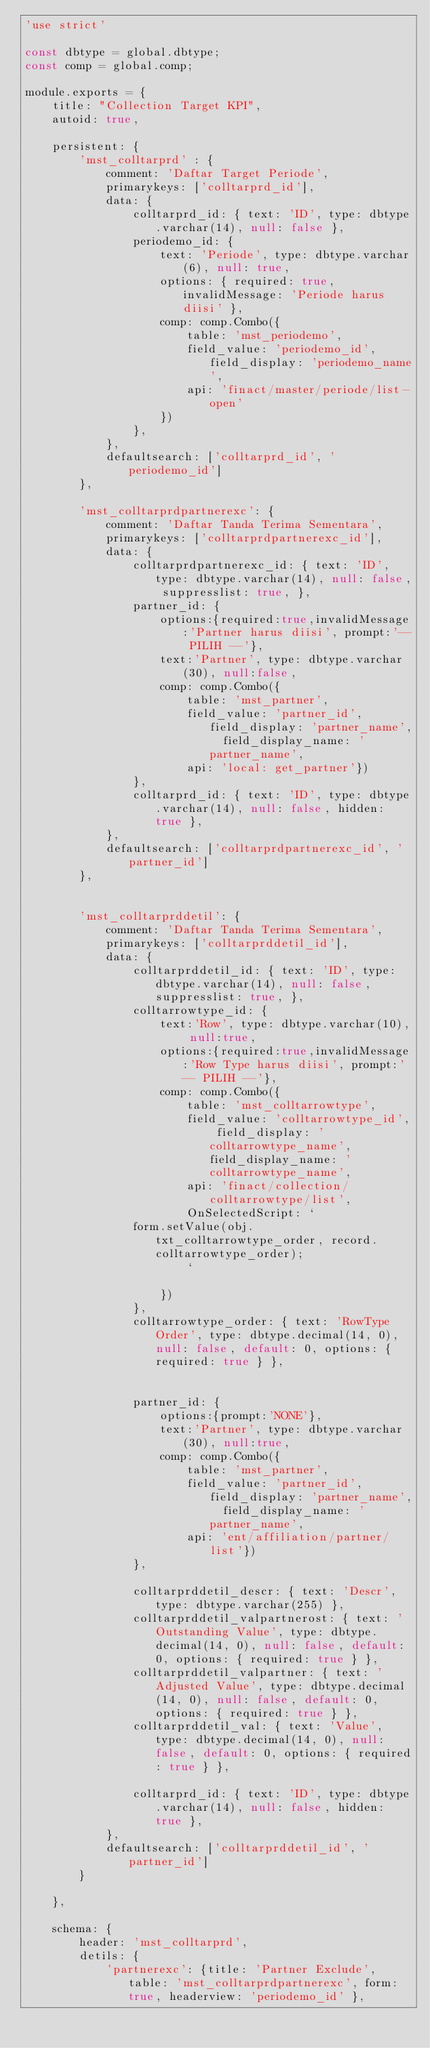Convert code to text. <code><loc_0><loc_0><loc_500><loc_500><_JavaScript_>'use strict'

const dbtype = global.dbtype;
const comp = global.comp;

module.exports = {
	title: "Collection Target KPI",
	autoid: true,

	persistent: {
		'mst_colltarprd' : {
			comment: 'Daftar Target Periode',
			primarykeys: ['colltarprd_id'],
			data: {
				colltarprd_id: { text: 'ID', type: dbtype.varchar(14), null: false },
				periodemo_id: { 
					text: 'Periode', type: dbtype.varchar(6), null: true,
					options: { required: true, invalidMessage: 'Periode harus diisi' }, 
					comp: comp.Combo({
						table: 'mst_periodemo',
						field_value: 'periodemo_id', field_display: 'periodemo_name',
						api: 'finact/master/periode/list-open'
					})				
				},
			},
			defaultsearch: ['colltarprd_id', 'periodemo_id']
		},

		'mst_colltarprdpartnerexc': {
			comment: 'Daftar Tanda Terima Sementara',
			primarykeys: ['colltarprdpartnerexc_id'],
			data: {
				colltarprdpartnerexc_id: { text: 'ID', type: dbtype.varchar(14), null: false, suppresslist: true, },
				partner_id: {
					options:{required:true,invalidMessage:'Partner harus diisi', prompt:'-- PILIH --'},
					text:'Partner', type: dbtype.varchar(30), null:false, 
					comp: comp.Combo({
						table: 'mst_partner', 
						field_value: 'partner_id', field_display: 'partner_name',  field_display_name: 'partner_name',
						api: 'local: get_partner'})
				},		
				colltarprd_id: { text: 'ID', type: dbtype.varchar(14), null: false, hidden: true },		
			},
			defaultsearch: ['colltarprdpartnerexc_id', 'partner_id']
		},


		'mst_colltarprddetil': {
			comment: 'Daftar Tanda Terima Sementara',
			primarykeys: ['colltarprddetil_id'],
			data: {
				colltarprddetil_id: { text: 'ID', type: dbtype.varchar(14), null: false, suppresslist: true, },
				colltarrowtype_id: {
					text:'Row', type: dbtype.varchar(10), null:true, 
					options:{required:true,invalidMessage:'Row Type harus diisi', prompt:'-- PILIH --'},
					comp: comp.Combo({
						table: 'mst_colltarrowtype', 
						field_value: 'colltarrowtype_id', field_display: 'colltarrowtype_name',  field_display_name: 'colltarrowtype_name',
						api: 'finact/collection/colltarrowtype/list',
						OnSelectedScript: `
				form.setValue(obj.txt_colltarrowtype_order, record.colltarrowtype_order);		
						`
					
					})
				},
				colltarrowtype_order: { text: 'RowType Order', type: dbtype.decimal(14, 0), null: false, default: 0, options: { required: true } },


				partner_id: {
					options:{prompt:'NONE'},
					text:'Partner', type: dbtype.varchar(30), null:true, 
					comp: comp.Combo({
						table: 'mst_partner', 
						field_value: 'partner_id', field_display: 'partner_name',  field_display_name: 'partner_name',
						api: 'ent/affiliation/partner/list'})
				},

				colltarprddetil_descr: { text: 'Descr', type: dbtype.varchar(255) },
				colltarprddetil_valpartnerost: { text: 'Outstanding Value', type: dbtype.decimal(14, 0), null: false, default: 0, options: { required: true } },
				colltarprddetil_valpartner: { text: 'Adjusted Value', type: dbtype.decimal(14, 0), null: false, default: 0, options: { required: true } },
				colltarprddetil_val: { text: 'Value', type: dbtype.decimal(14, 0), null: false, default: 0, options: { required: true } },

				colltarprd_id: { text: 'ID', type: dbtype.varchar(14), null: false, hidden: true },		
			},
			defaultsearch: ['colltarprddetil_id', 'partner_id']
		}		
	
	},

	schema: {
		header: 'mst_colltarprd',
		detils: {
			'partnerexc': {title: 'Partner Exclude', table: 'mst_colltarprdpartnerexc', form: true, headerview: 'periodemo_id' },</code> 